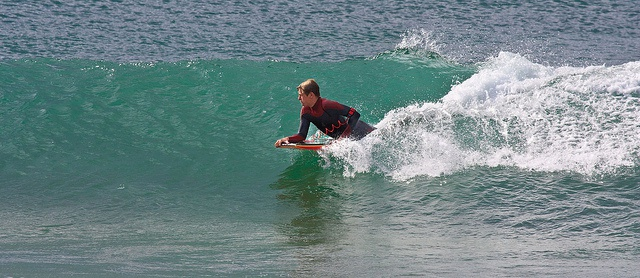Describe the objects in this image and their specific colors. I can see people in gray, black, maroon, and brown tones and surfboard in gray, black, and brown tones in this image. 